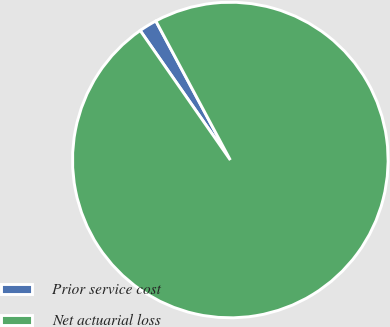Convert chart. <chart><loc_0><loc_0><loc_500><loc_500><pie_chart><fcel>Prior service cost<fcel>Net actuarial loss<nl><fcel>1.85%<fcel>98.15%<nl></chart> 